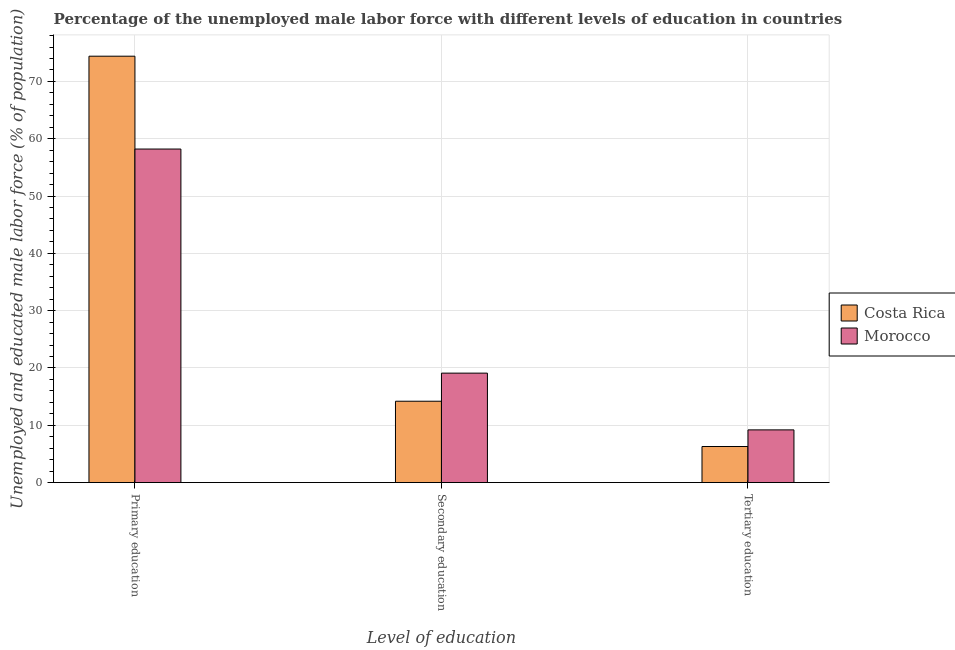How many different coloured bars are there?
Provide a short and direct response. 2. Are the number of bars per tick equal to the number of legend labels?
Your answer should be compact. Yes. Are the number of bars on each tick of the X-axis equal?
Make the answer very short. Yes. How many bars are there on the 3rd tick from the right?
Ensure brevity in your answer.  2. What is the label of the 3rd group of bars from the left?
Your answer should be compact. Tertiary education. What is the percentage of male labor force who received primary education in Costa Rica?
Your response must be concise. 74.4. Across all countries, what is the maximum percentage of male labor force who received tertiary education?
Offer a terse response. 9.2. Across all countries, what is the minimum percentage of male labor force who received tertiary education?
Your answer should be compact. 6.3. In which country was the percentage of male labor force who received secondary education maximum?
Offer a very short reply. Morocco. In which country was the percentage of male labor force who received tertiary education minimum?
Give a very brief answer. Costa Rica. What is the difference between the percentage of male labor force who received tertiary education in Costa Rica and that in Morocco?
Offer a terse response. -2.9. What is the difference between the percentage of male labor force who received tertiary education in Morocco and the percentage of male labor force who received primary education in Costa Rica?
Your answer should be very brief. -65.2. What is the average percentage of male labor force who received primary education per country?
Your answer should be very brief. 66.3. What is the difference between the percentage of male labor force who received secondary education and percentage of male labor force who received tertiary education in Costa Rica?
Make the answer very short. 7.9. In how many countries, is the percentage of male labor force who received tertiary education greater than 10 %?
Offer a terse response. 0. What is the ratio of the percentage of male labor force who received secondary education in Morocco to that in Costa Rica?
Keep it short and to the point. 1.35. What is the difference between the highest and the second highest percentage of male labor force who received secondary education?
Offer a terse response. 4.9. What is the difference between the highest and the lowest percentage of male labor force who received secondary education?
Your answer should be very brief. 4.9. What does the 1st bar from the left in Primary education represents?
Provide a succinct answer. Costa Rica. What does the 1st bar from the right in Secondary education represents?
Provide a short and direct response. Morocco. Is it the case that in every country, the sum of the percentage of male labor force who received primary education and percentage of male labor force who received secondary education is greater than the percentage of male labor force who received tertiary education?
Provide a succinct answer. Yes. How many bars are there?
Keep it short and to the point. 6. What is the difference between two consecutive major ticks on the Y-axis?
Give a very brief answer. 10. Does the graph contain grids?
Your answer should be very brief. Yes. How are the legend labels stacked?
Your answer should be very brief. Vertical. What is the title of the graph?
Make the answer very short. Percentage of the unemployed male labor force with different levels of education in countries. What is the label or title of the X-axis?
Give a very brief answer. Level of education. What is the label or title of the Y-axis?
Provide a succinct answer. Unemployed and educated male labor force (% of population). What is the Unemployed and educated male labor force (% of population) in Costa Rica in Primary education?
Give a very brief answer. 74.4. What is the Unemployed and educated male labor force (% of population) in Morocco in Primary education?
Provide a short and direct response. 58.2. What is the Unemployed and educated male labor force (% of population) in Costa Rica in Secondary education?
Keep it short and to the point. 14.2. What is the Unemployed and educated male labor force (% of population) in Morocco in Secondary education?
Offer a very short reply. 19.1. What is the Unemployed and educated male labor force (% of population) in Costa Rica in Tertiary education?
Offer a terse response. 6.3. What is the Unemployed and educated male labor force (% of population) in Morocco in Tertiary education?
Your answer should be compact. 9.2. Across all Level of education, what is the maximum Unemployed and educated male labor force (% of population) in Costa Rica?
Provide a short and direct response. 74.4. Across all Level of education, what is the maximum Unemployed and educated male labor force (% of population) in Morocco?
Ensure brevity in your answer.  58.2. Across all Level of education, what is the minimum Unemployed and educated male labor force (% of population) of Costa Rica?
Your response must be concise. 6.3. Across all Level of education, what is the minimum Unemployed and educated male labor force (% of population) in Morocco?
Offer a terse response. 9.2. What is the total Unemployed and educated male labor force (% of population) in Costa Rica in the graph?
Make the answer very short. 94.9. What is the total Unemployed and educated male labor force (% of population) of Morocco in the graph?
Offer a very short reply. 86.5. What is the difference between the Unemployed and educated male labor force (% of population) in Costa Rica in Primary education and that in Secondary education?
Provide a succinct answer. 60.2. What is the difference between the Unemployed and educated male labor force (% of population) in Morocco in Primary education and that in Secondary education?
Offer a terse response. 39.1. What is the difference between the Unemployed and educated male labor force (% of population) in Costa Rica in Primary education and that in Tertiary education?
Offer a terse response. 68.1. What is the difference between the Unemployed and educated male labor force (% of population) of Morocco in Primary education and that in Tertiary education?
Make the answer very short. 49. What is the difference between the Unemployed and educated male labor force (% of population) of Costa Rica in Secondary education and that in Tertiary education?
Your answer should be very brief. 7.9. What is the difference between the Unemployed and educated male labor force (% of population) in Costa Rica in Primary education and the Unemployed and educated male labor force (% of population) in Morocco in Secondary education?
Provide a succinct answer. 55.3. What is the difference between the Unemployed and educated male labor force (% of population) of Costa Rica in Primary education and the Unemployed and educated male labor force (% of population) of Morocco in Tertiary education?
Ensure brevity in your answer.  65.2. What is the difference between the Unemployed and educated male labor force (% of population) of Costa Rica in Secondary education and the Unemployed and educated male labor force (% of population) of Morocco in Tertiary education?
Your answer should be compact. 5. What is the average Unemployed and educated male labor force (% of population) in Costa Rica per Level of education?
Provide a short and direct response. 31.63. What is the average Unemployed and educated male labor force (% of population) of Morocco per Level of education?
Give a very brief answer. 28.83. What is the ratio of the Unemployed and educated male labor force (% of population) in Costa Rica in Primary education to that in Secondary education?
Your response must be concise. 5.24. What is the ratio of the Unemployed and educated male labor force (% of population) of Morocco in Primary education to that in Secondary education?
Give a very brief answer. 3.05. What is the ratio of the Unemployed and educated male labor force (% of population) in Costa Rica in Primary education to that in Tertiary education?
Offer a very short reply. 11.81. What is the ratio of the Unemployed and educated male labor force (% of population) in Morocco in Primary education to that in Tertiary education?
Your response must be concise. 6.33. What is the ratio of the Unemployed and educated male labor force (% of population) of Costa Rica in Secondary education to that in Tertiary education?
Your answer should be compact. 2.25. What is the ratio of the Unemployed and educated male labor force (% of population) of Morocco in Secondary education to that in Tertiary education?
Your response must be concise. 2.08. What is the difference between the highest and the second highest Unemployed and educated male labor force (% of population) in Costa Rica?
Your response must be concise. 60.2. What is the difference between the highest and the second highest Unemployed and educated male labor force (% of population) in Morocco?
Keep it short and to the point. 39.1. What is the difference between the highest and the lowest Unemployed and educated male labor force (% of population) in Costa Rica?
Offer a terse response. 68.1. 